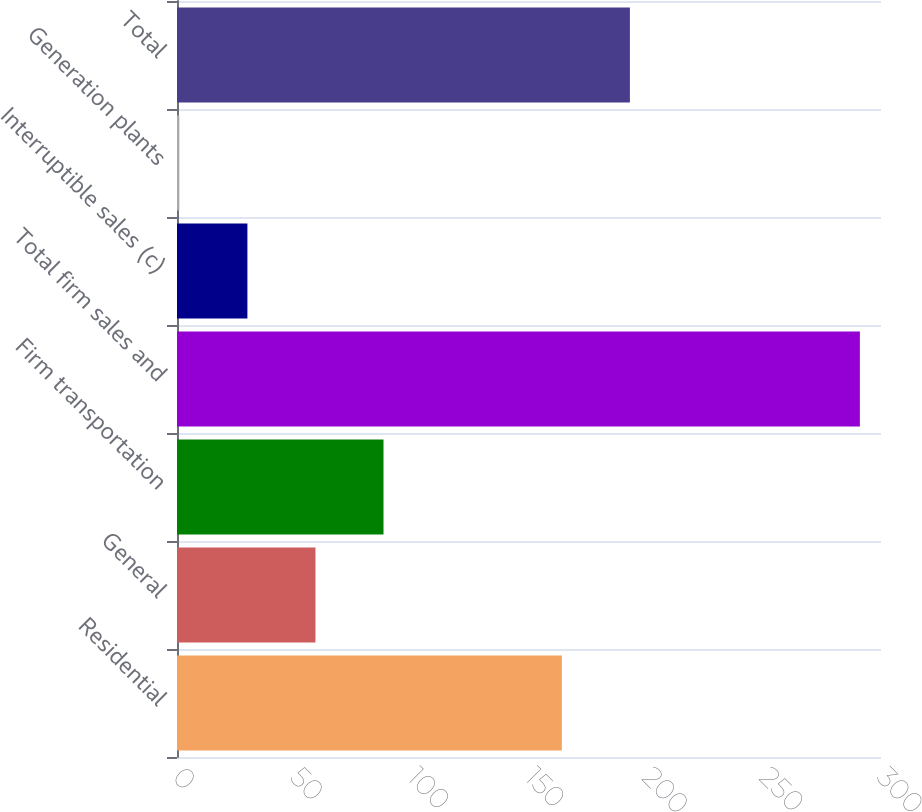Convert chart. <chart><loc_0><loc_0><loc_500><loc_500><bar_chart><fcel>Residential<fcel>General<fcel>Firm transportation<fcel>Total firm sales and<fcel>Interruptible sales (c)<fcel>Generation plants<fcel>Total<nl><fcel>164<fcel>59<fcel>88<fcel>291<fcel>30<fcel>1<fcel>193<nl></chart> 